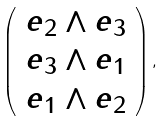Convert formula to latex. <formula><loc_0><loc_0><loc_500><loc_500>\left ( \begin{array} { c } e _ { 2 } \wedge e _ { 3 } \\ e _ { 3 } \wedge e _ { 1 } \\ e _ { 1 } \wedge e _ { 2 } \end{array} \right ) ,</formula> 